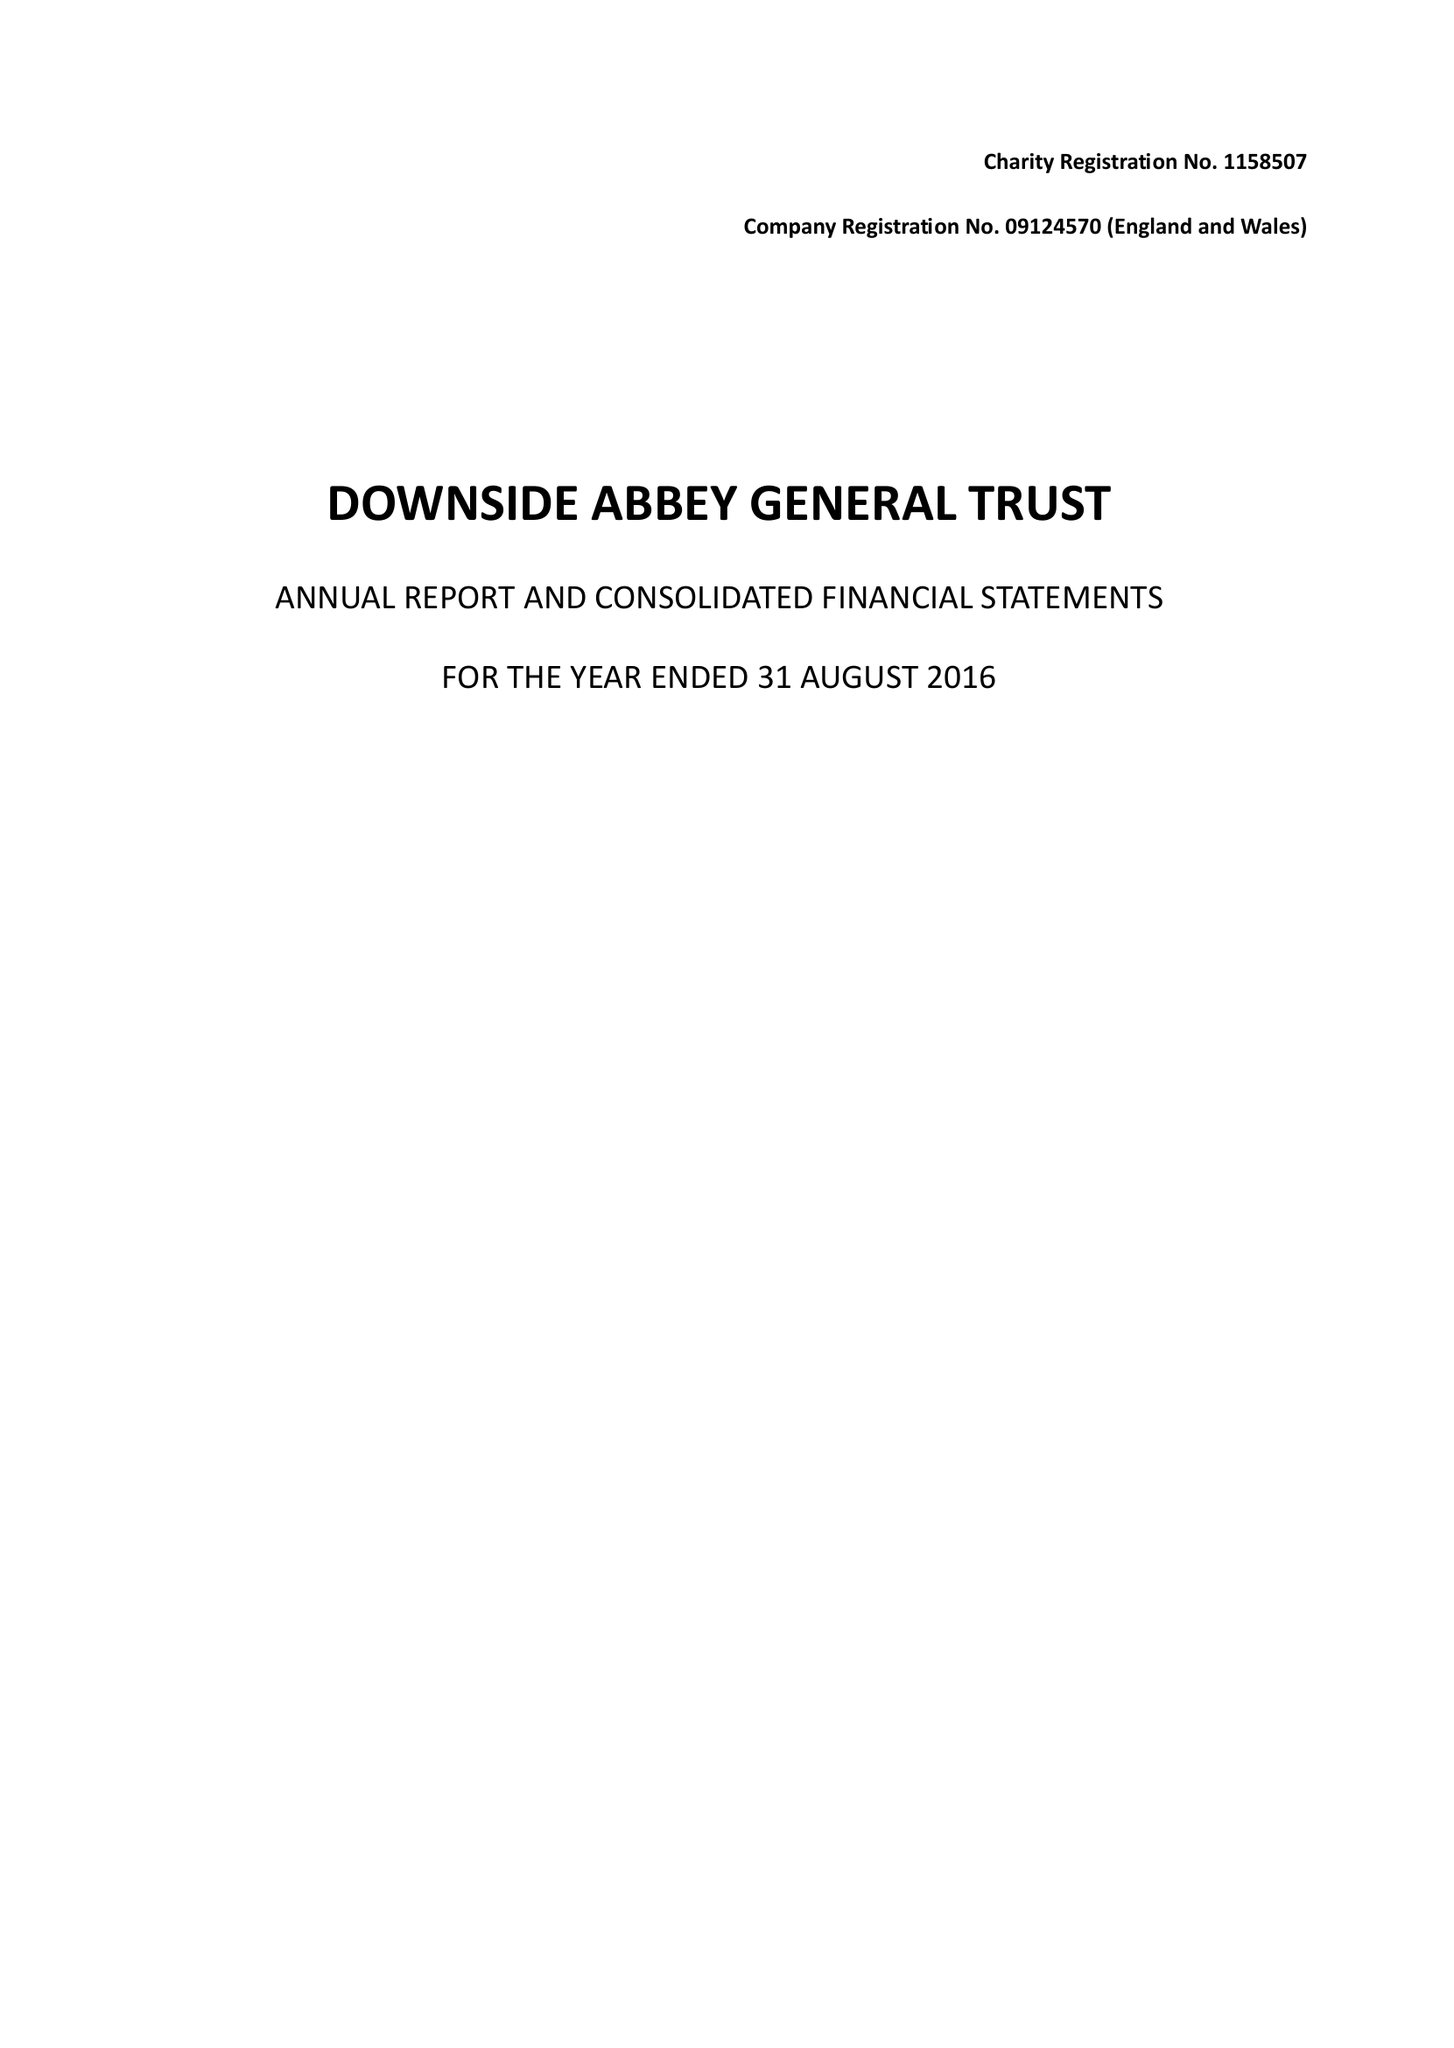What is the value for the charity_number?
Answer the question using a single word or phrase. 1158507 